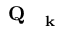<formula> <loc_0><loc_0><loc_500><loc_500>Q _ { k }</formula> 